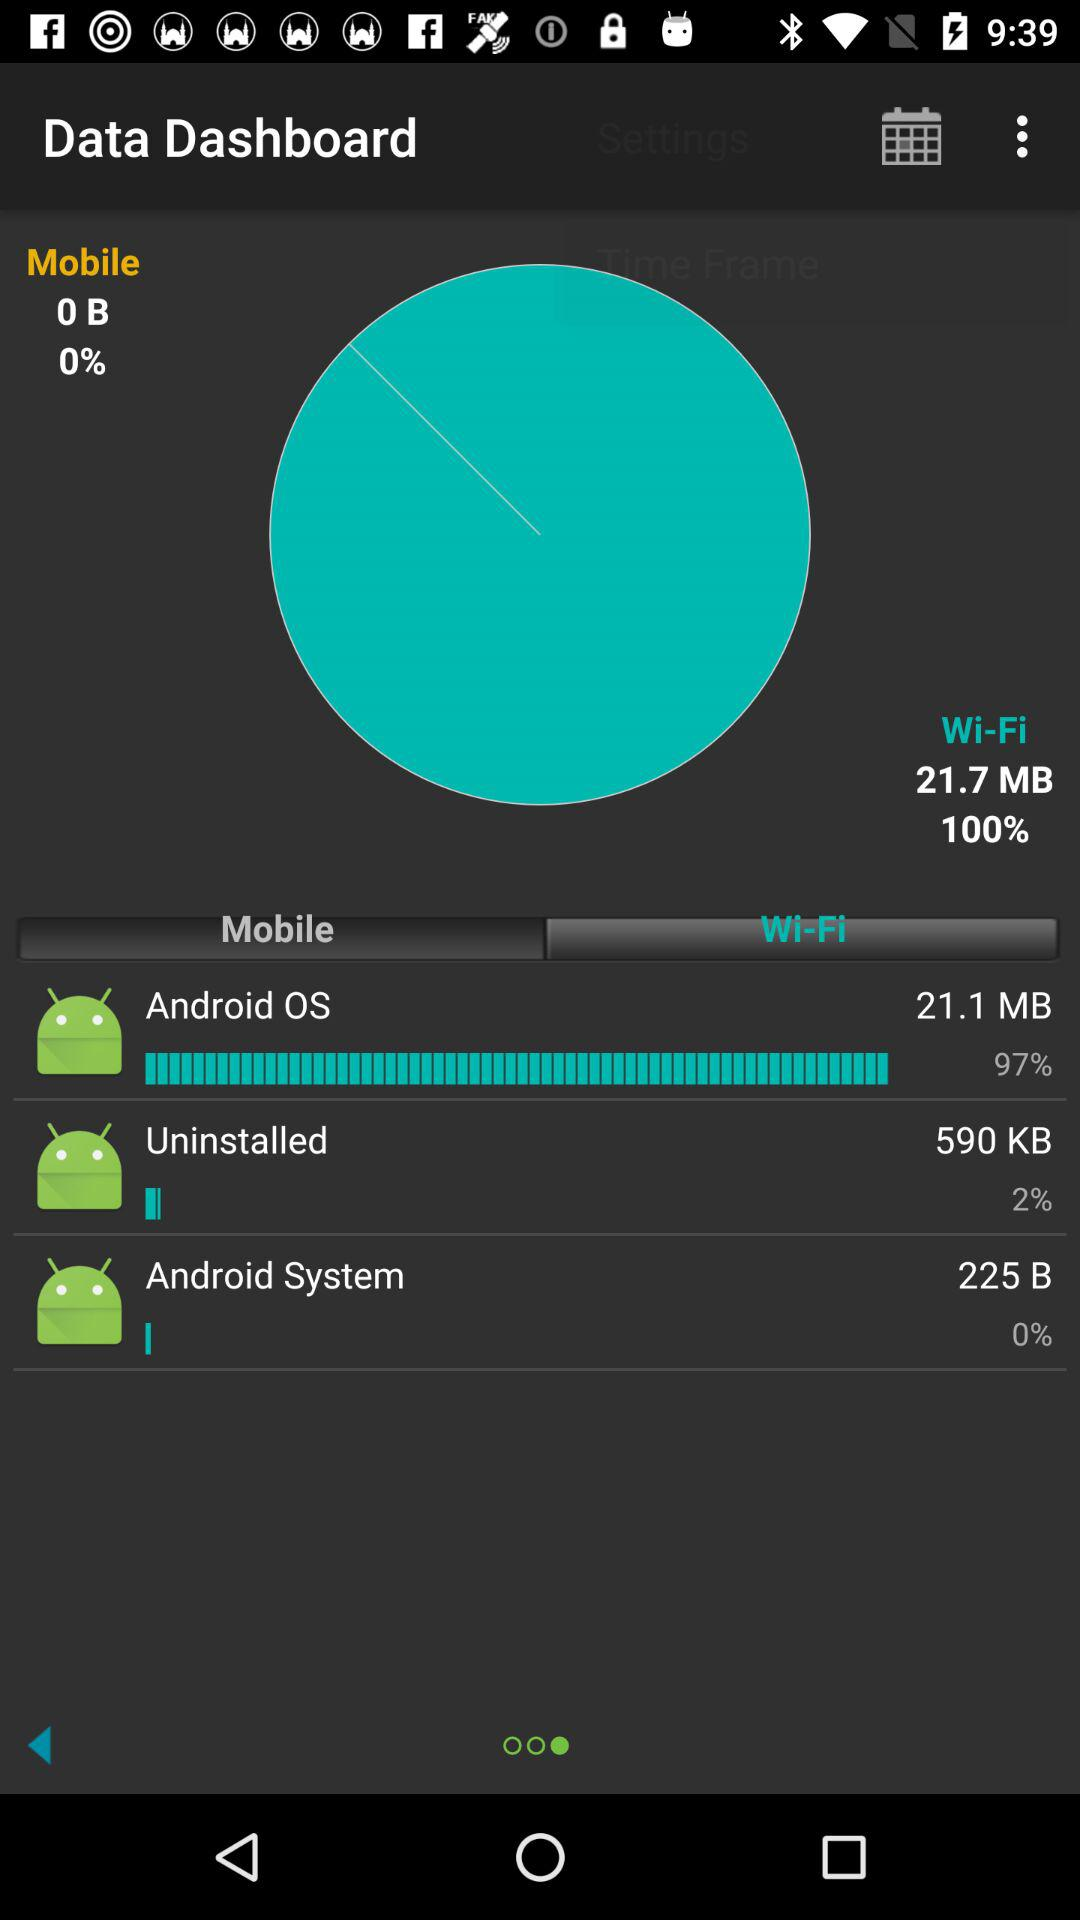Which app has the highest percentage of data usage?
Answer the question using a single word or phrase. Android OS 